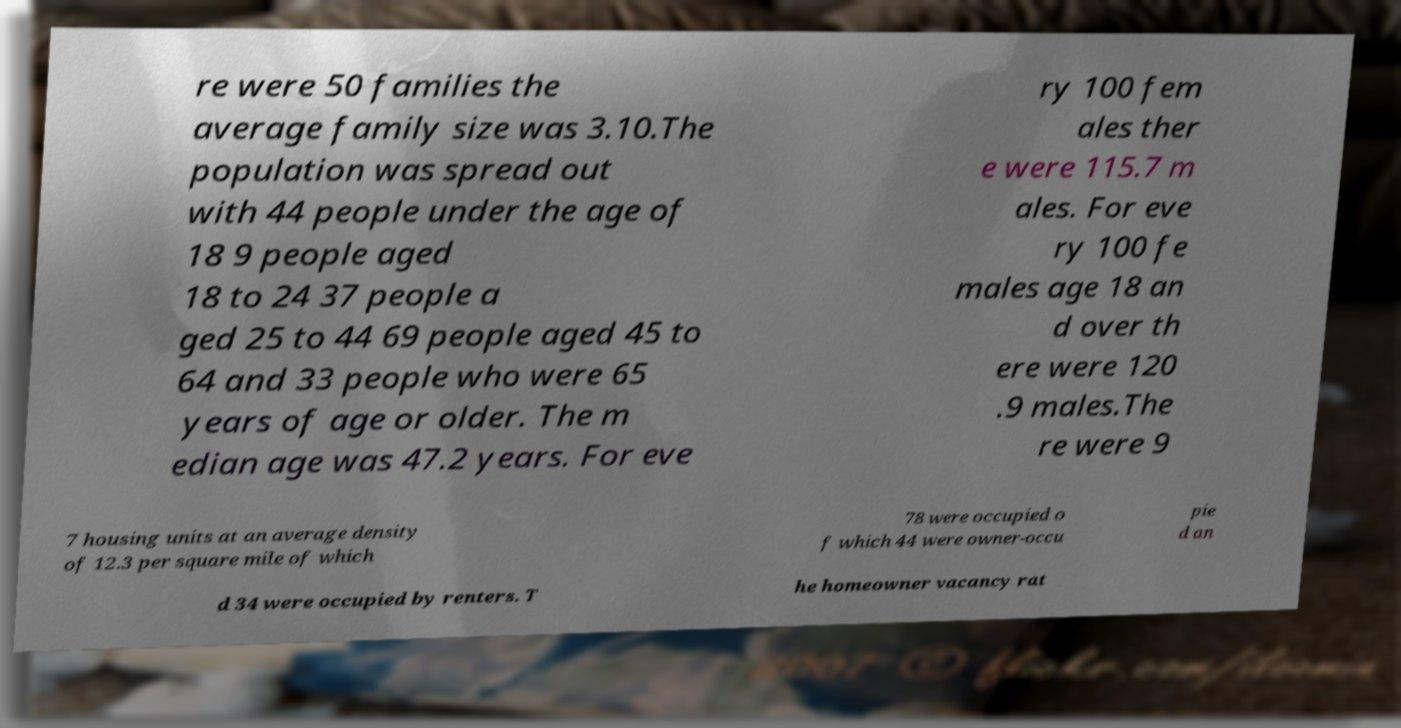Please identify and transcribe the text found in this image. re were 50 families the average family size was 3.10.The population was spread out with 44 people under the age of 18 9 people aged 18 to 24 37 people a ged 25 to 44 69 people aged 45 to 64 and 33 people who were 65 years of age or older. The m edian age was 47.2 years. For eve ry 100 fem ales ther e were 115.7 m ales. For eve ry 100 fe males age 18 an d over th ere were 120 .9 males.The re were 9 7 housing units at an average density of 12.3 per square mile of which 78 were occupied o f which 44 were owner-occu pie d an d 34 were occupied by renters. T he homeowner vacancy rat 